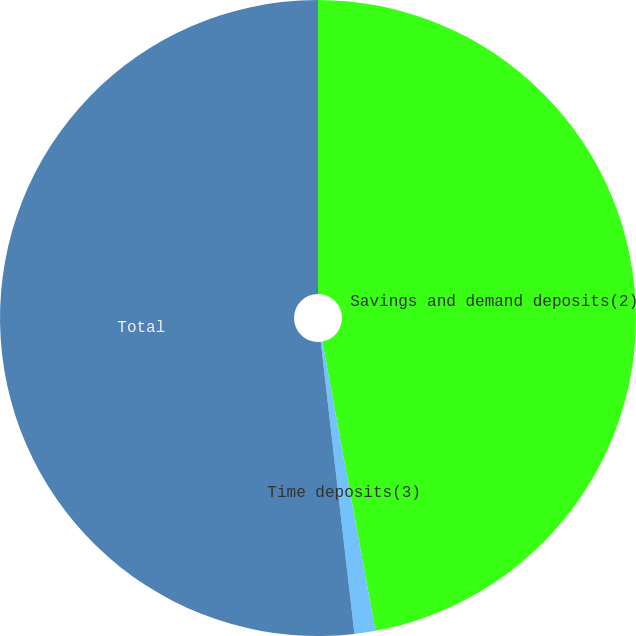Convert chart to OTSL. <chart><loc_0><loc_0><loc_500><loc_500><pie_chart><fcel>Savings and demand deposits(2)<fcel>Time deposits(3)<fcel>Total<nl><fcel>47.11%<fcel>1.06%<fcel>51.83%<nl></chart> 